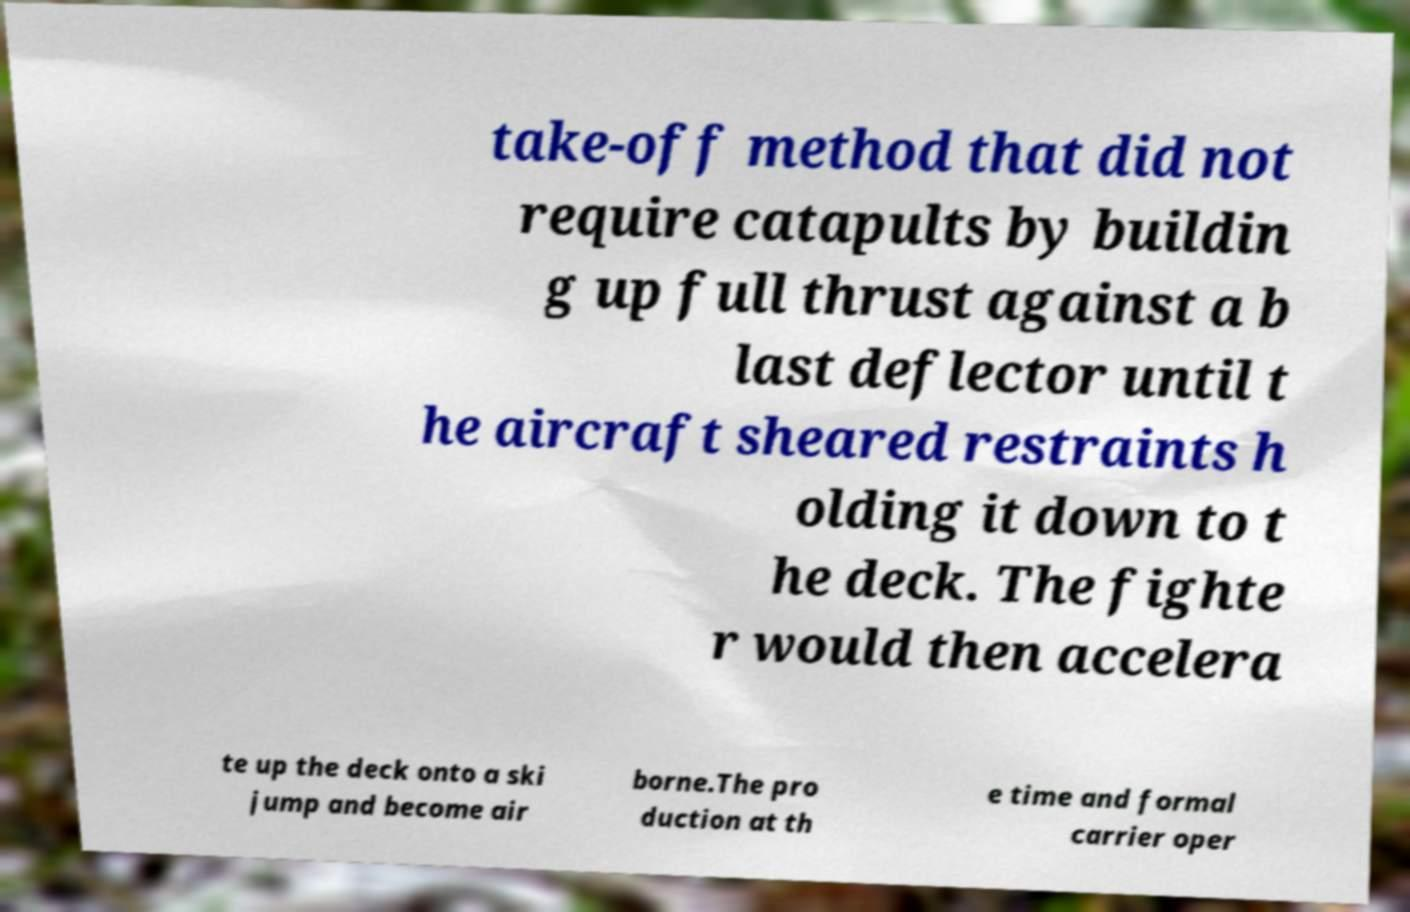What messages or text are displayed in this image? I need them in a readable, typed format. take-off method that did not require catapults by buildin g up full thrust against a b last deflector until t he aircraft sheared restraints h olding it down to t he deck. The fighte r would then accelera te up the deck onto a ski jump and become air borne.The pro duction at th e time and formal carrier oper 